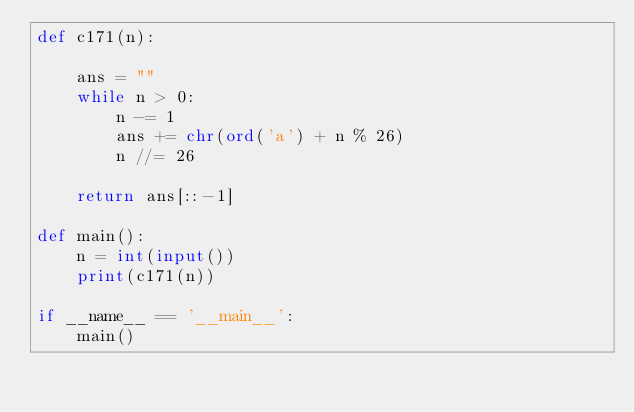<code> <loc_0><loc_0><loc_500><loc_500><_Python_>def c171(n):

    ans = ""
    while n > 0:
        n -= 1
        ans += chr(ord('a') + n % 26)
        n //= 26

    return ans[::-1]

def main():
    n = int(input())
    print(c171(n))

if __name__ == '__main__':
    main()
</code> 